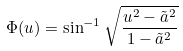<formula> <loc_0><loc_0><loc_500><loc_500>\Phi ( u ) = \sin ^ { - 1 } \sqrt { \frac { u ^ { 2 } - \tilde { a } ^ { 2 } } { 1 - \tilde { a } ^ { 2 } } }</formula> 